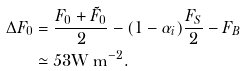Convert formula to latex. <formula><loc_0><loc_0><loc_500><loc_500>\Delta F _ { 0 } & = \frac { F _ { 0 } + \tilde { F } _ { 0 } } { 2 } - ( 1 - \alpha _ { i } ) \frac { F _ { S } } { 2 } - F _ { B } \\ & \simeq 5 3 \text {W m} ^ { - 2 } .</formula> 